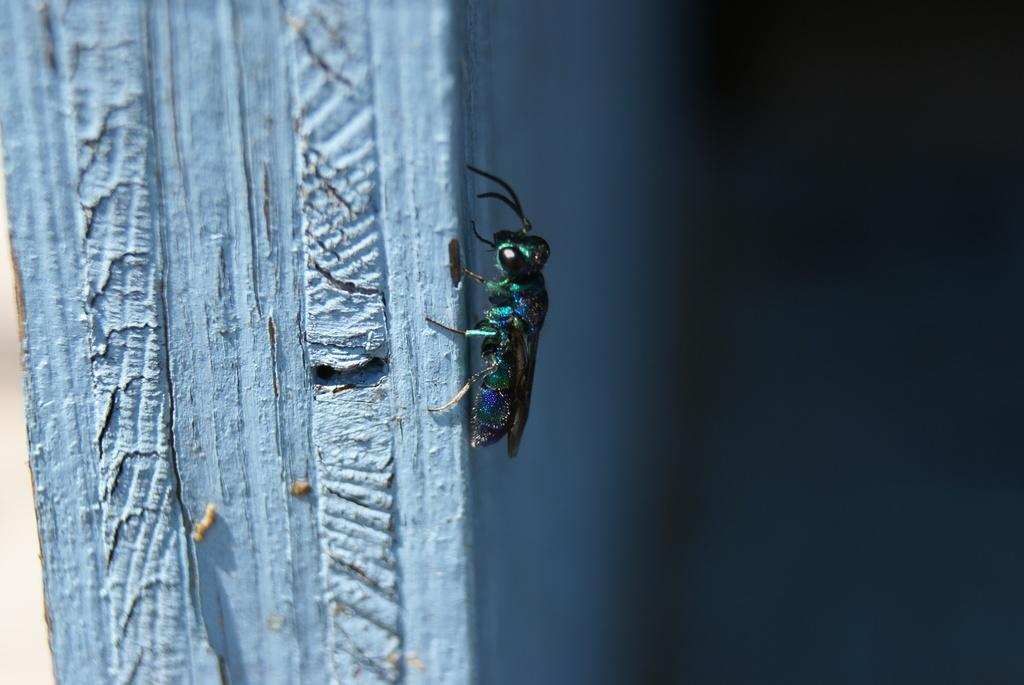What type of creature can be seen in the image? There is an insect in the image. What is the color of the surface where the insect is located? The insect is on a blue surface. How many boats are visible in the image? There are no boats present in the image; it features an insect on a blue surface. What type of flame can be seen near the insect in the image? There is no flame present in the image; it features an insect on a blue surface. 